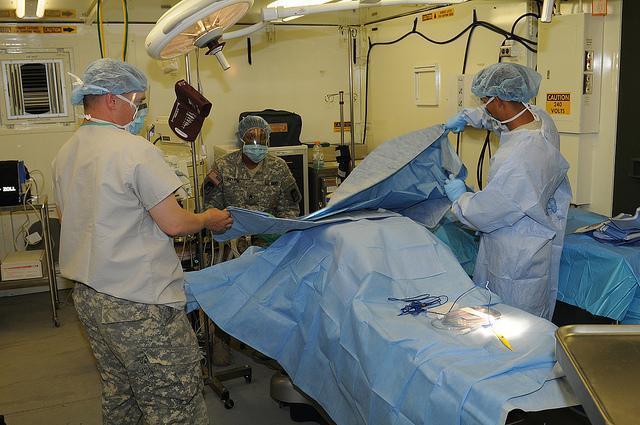How many people can be seen?
Give a very brief answer. 3. How many cats are in the image?
Give a very brief answer. 0. 